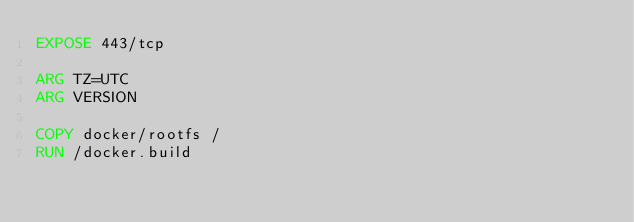Convert code to text. <code><loc_0><loc_0><loc_500><loc_500><_Dockerfile_>EXPOSE 443/tcp

ARG TZ=UTC
ARG VERSION

COPY docker/rootfs /
RUN /docker.build
</code> 